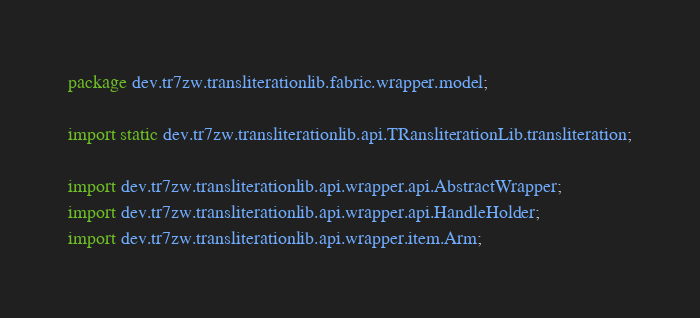Convert code to text. <code><loc_0><loc_0><loc_500><loc_500><_Java_>package dev.tr7zw.transliterationlib.fabric.wrapper.model;

import static dev.tr7zw.transliterationlib.api.TRansliterationLib.transliteration;

import dev.tr7zw.transliterationlib.api.wrapper.api.AbstractWrapper;
import dev.tr7zw.transliterationlib.api.wrapper.api.HandleHolder;
import dev.tr7zw.transliterationlib.api.wrapper.item.Arm;</code> 